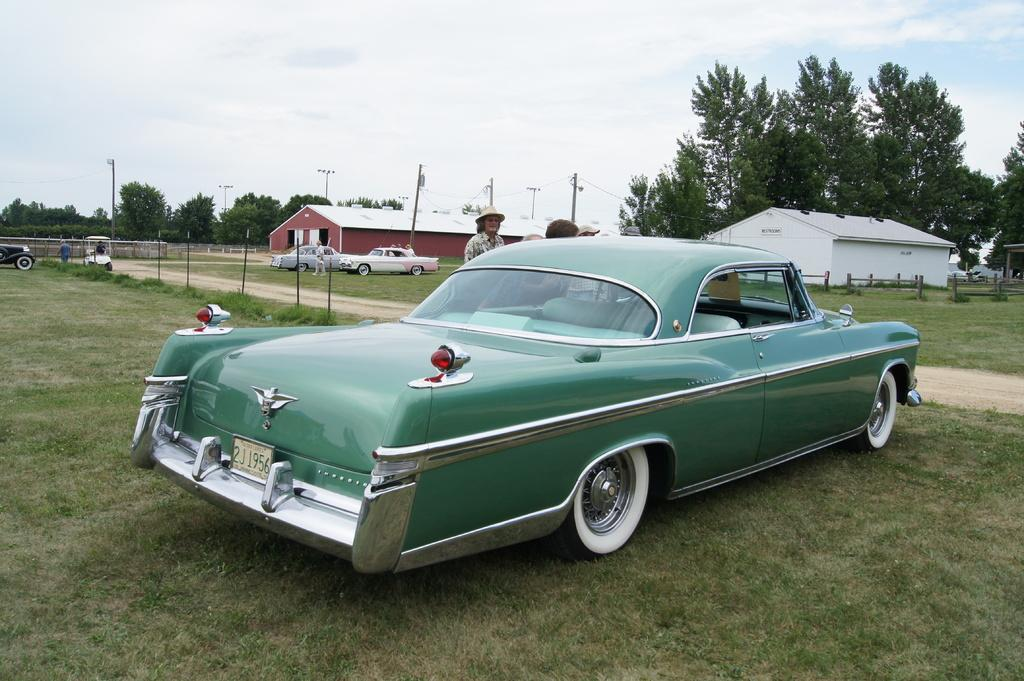What type of vehicles can be seen in the image? There are cars in the image. Who or what else is present in the image? There are people in the image. What type of vegetation is at the bottom of the image? There is grass at the bottom of the image. What structures can be seen in the background of the image? There are sheds, trees, and poles in the background of the image. What part of the natural environment is visible in the background of the image? The sky is visible in the background of the image. What type of string is being used by the tramp in the image? There is no tramp or string present in the image. What day of the week is depicted in the image? The image does not depict a specific day of the week. 